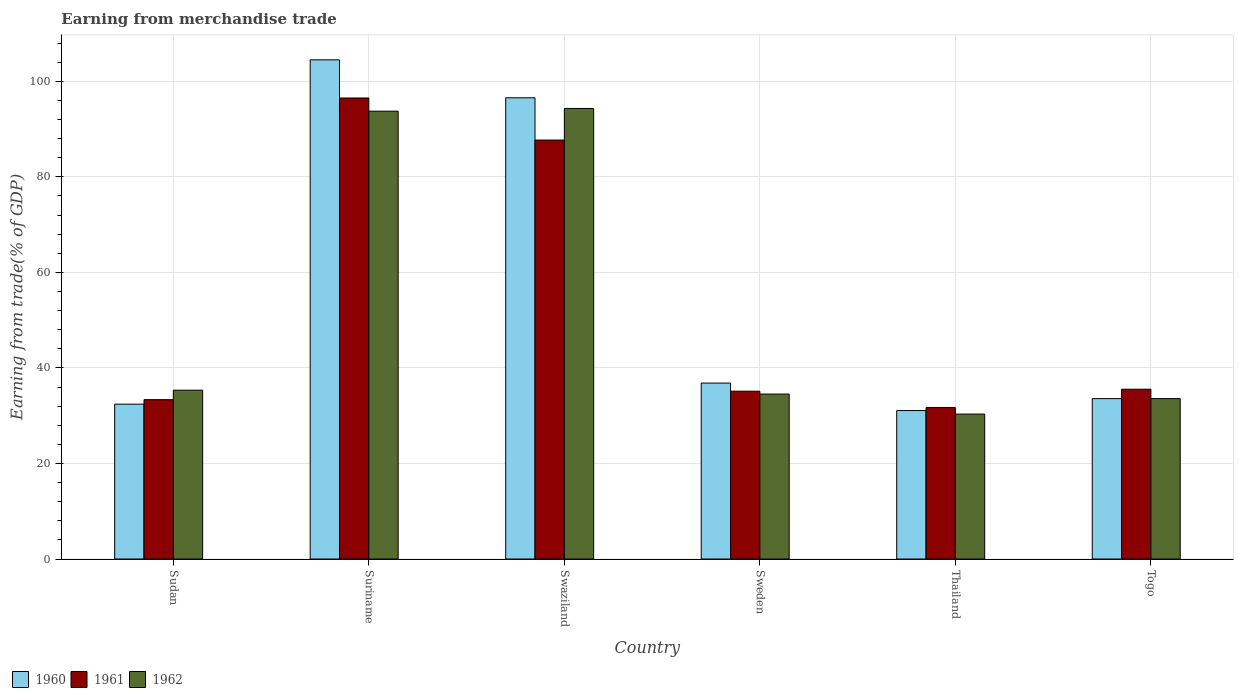How many groups of bars are there?
Make the answer very short. 6. What is the label of the 5th group of bars from the left?
Give a very brief answer. Thailand. What is the earnings from trade in 1961 in Swaziland?
Your response must be concise. 87.71. Across all countries, what is the maximum earnings from trade in 1962?
Your response must be concise. 94.33. Across all countries, what is the minimum earnings from trade in 1962?
Your response must be concise. 30.34. In which country was the earnings from trade in 1961 maximum?
Offer a very short reply. Suriname. In which country was the earnings from trade in 1960 minimum?
Provide a succinct answer. Thailand. What is the total earnings from trade in 1961 in the graph?
Keep it short and to the point. 319.97. What is the difference between the earnings from trade in 1962 in Swaziland and that in Sweden?
Your response must be concise. 59.79. What is the difference between the earnings from trade in 1961 in Sudan and the earnings from trade in 1962 in Suriname?
Your answer should be compact. -60.4. What is the average earnings from trade in 1960 per country?
Give a very brief answer. 55.83. What is the difference between the earnings from trade of/in 1962 and earnings from trade of/in 1960 in Swaziland?
Provide a short and direct response. -2.23. What is the ratio of the earnings from trade in 1960 in Suriname to that in Thailand?
Ensure brevity in your answer.  3.36. Is the earnings from trade in 1962 in Sweden less than that in Togo?
Provide a short and direct response. No. What is the difference between the highest and the second highest earnings from trade in 1962?
Your answer should be compact. -58.41. What is the difference between the highest and the lowest earnings from trade in 1961?
Keep it short and to the point. 64.81. Is the sum of the earnings from trade in 1961 in Swaziland and Sweden greater than the maximum earnings from trade in 1962 across all countries?
Offer a terse response. Yes. What does the 1st bar from the right in Sudan represents?
Offer a very short reply. 1962. How many bars are there?
Provide a succinct answer. 18. How many countries are there in the graph?
Your answer should be compact. 6. Where does the legend appear in the graph?
Keep it short and to the point. Bottom left. How are the legend labels stacked?
Your answer should be compact. Horizontal. What is the title of the graph?
Your answer should be compact. Earning from merchandise trade. What is the label or title of the Y-axis?
Offer a very short reply. Earning from trade(% of GDP). What is the Earning from trade(% of GDP) in 1960 in Sudan?
Ensure brevity in your answer.  32.42. What is the Earning from trade(% of GDP) in 1961 in Sudan?
Your answer should be compact. 33.36. What is the Earning from trade(% of GDP) in 1962 in Sudan?
Offer a very short reply. 35.34. What is the Earning from trade(% of GDP) of 1960 in Suriname?
Your answer should be very brief. 104.5. What is the Earning from trade(% of GDP) in 1961 in Suriname?
Ensure brevity in your answer.  96.51. What is the Earning from trade(% of GDP) in 1962 in Suriname?
Ensure brevity in your answer.  93.76. What is the Earning from trade(% of GDP) of 1960 in Swaziland?
Your answer should be very brief. 96.56. What is the Earning from trade(% of GDP) in 1961 in Swaziland?
Make the answer very short. 87.71. What is the Earning from trade(% of GDP) in 1962 in Swaziland?
Ensure brevity in your answer.  94.33. What is the Earning from trade(% of GDP) of 1960 in Sweden?
Your answer should be compact. 36.83. What is the Earning from trade(% of GDP) of 1961 in Sweden?
Your response must be concise. 35.13. What is the Earning from trade(% of GDP) in 1962 in Sweden?
Your response must be concise. 34.53. What is the Earning from trade(% of GDP) in 1960 in Thailand?
Your answer should be compact. 31.08. What is the Earning from trade(% of GDP) in 1961 in Thailand?
Make the answer very short. 31.71. What is the Earning from trade(% of GDP) in 1962 in Thailand?
Ensure brevity in your answer.  30.34. What is the Earning from trade(% of GDP) of 1960 in Togo?
Offer a very short reply. 33.58. What is the Earning from trade(% of GDP) of 1961 in Togo?
Provide a short and direct response. 35.55. What is the Earning from trade(% of GDP) in 1962 in Togo?
Give a very brief answer. 33.58. Across all countries, what is the maximum Earning from trade(% of GDP) in 1960?
Ensure brevity in your answer.  104.5. Across all countries, what is the maximum Earning from trade(% of GDP) in 1961?
Make the answer very short. 96.51. Across all countries, what is the maximum Earning from trade(% of GDP) of 1962?
Offer a terse response. 94.33. Across all countries, what is the minimum Earning from trade(% of GDP) in 1960?
Give a very brief answer. 31.08. Across all countries, what is the minimum Earning from trade(% of GDP) of 1961?
Provide a short and direct response. 31.71. Across all countries, what is the minimum Earning from trade(% of GDP) of 1962?
Your answer should be compact. 30.34. What is the total Earning from trade(% of GDP) in 1960 in the graph?
Provide a succinct answer. 334.97. What is the total Earning from trade(% of GDP) in 1961 in the graph?
Offer a very short reply. 319.97. What is the total Earning from trade(% of GDP) of 1962 in the graph?
Your answer should be very brief. 321.89. What is the difference between the Earning from trade(% of GDP) of 1960 in Sudan and that in Suriname?
Make the answer very short. -72.09. What is the difference between the Earning from trade(% of GDP) in 1961 in Sudan and that in Suriname?
Ensure brevity in your answer.  -63.16. What is the difference between the Earning from trade(% of GDP) of 1962 in Sudan and that in Suriname?
Provide a succinct answer. -58.41. What is the difference between the Earning from trade(% of GDP) in 1960 in Sudan and that in Swaziland?
Your answer should be compact. -64.14. What is the difference between the Earning from trade(% of GDP) in 1961 in Sudan and that in Swaziland?
Offer a terse response. -54.35. What is the difference between the Earning from trade(% of GDP) in 1962 in Sudan and that in Swaziland?
Your answer should be very brief. -58.98. What is the difference between the Earning from trade(% of GDP) of 1960 in Sudan and that in Sweden?
Provide a short and direct response. -4.41. What is the difference between the Earning from trade(% of GDP) in 1961 in Sudan and that in Sweden?
Your response must be concise. -1.78. What is the difference between the Earning from trade(% of GDP) of 1962 in Sudan and that in Sweden?
Provide a short and direct response. 0.81. What is the difference between the Earning from trade(% of GDP) in 1960 in Sudan and that in Thailand?
Offer a terse response. 1.34. What is the difference between the Earning from trade(% of GDP) of 1961 in Sudan and that in Thailand?
Offer a very short reply. 1.65. What is the difference between the Earning from trade(% of GDP) in 1962 in Sudan and that in Thailand?
Your response must be concise. 5. What is the difference between the Earning from trade(% of GDP) in 1960 in Sudan and that in Togo?
Provide a short and direct response. -1.16. What is the difference between the Earning from trade(% of GDP) in 1961 in Sudan and that in Togo?
Your answer should be compact. -2.19. What is the difference between the Earning from trade(% of GDP) in 1962 in Sudan and that in Togo?
Provide a short and direct response. 1.76. What is the difference between the Earning from trade(% of GDP) of 1960 in Suriname and that in Swaziland?
Provide a short and direct response. 7.94. What is the difference between the Earning from trade(% of GDP) in 1961 in Suriname and that in Swaziland?
Provide a short and direct response. 8.8. What is the difference between the Earning from trade(% of GDP) of 1962 in Suriname and that in Swaziland?
Give a very brief answer. -0.57. What is the difference between the Earning from trade(% of GDP) of 1960 in Suriname and that in Sweden?
Provide a succinct answer. 67.67. What is the difference between the Earning from trade(% of GDP) in 1961 in Suriname and that in Sweden?
Provide a short and direct response. 61.38. What is the difference between the Earning from trade(% of GDP) in 1962 in Suriname and that in Sweden?
Provide a succinct answer. 59.22. What is the difference between the Earning from trade(% of GDP) in 1960 in Suriname and that in Thailand?
Make the answer very short. 73.43. What is the difference between the Earning from trade(% of GDP) of 1961 in Suriname and that in Thailand?
Keep it short and to the point. 64.81. What is the difference between the Earning from trade(% of GDP) of 1962 in Suriname and that in Thailand?
Provide a succinct answer. 63.41. What is the difference between the Earning from trade(% of GDP) in 1960 in Suriname and that in Togo?
Your answer should be very brief. 70.93. What is the difference between the Earning from trade(% of GDP) in 1961 in Suriname and that in Togo?
Give a very brief answer. 60.97. What is the difference between the Earning from trade(% of GDP) in 1962 in Suriname and that in Togo?
Your response must be concise. 60.17. What is the difference between the Earning from trade(% of GDP) in 1960 in Swaziland and that in Sweden?
Offer a very short reply. 59.73. What is the difference between the Earning from trade(% of GDP) in 1961 in Swaziland and that in Sweden?
Offer a very short reply. 52.58. What is the difference between the Earning from trade(% of GDP) in 1962 in Swaziland and that in Sweden?
Your answer should be very brief. 59.79. What is the difference between the Earning from trade(% of GDP) in 1960 in Swaziland and that in Thailand?
Offer a very short reply. 65.48. What is the difference between the Earning from trade(% of GDP) in 1961 in Swaziland and that in Thailand?
Your answer should be compact. 56. What is the difference between the Earning from trade(% of GDP) of 1962 in Swaziland and that in Thailand?
Provide a succinct answer. 63.98. What is the difference between the Earning from trade(% of GDP) of 1960 in Swaziland and that in Togo?
Your answer should be compact. 62.98. What is the difference between the Earning from trade(% of GDP) of 1961 in Swaziland and that in Togo?
Provide a succinct answer. 52.16. What is the difference between the Earning from trade(% of GDP) in 1962 in Swaziland and that in Togo?
Your answer should be very brief. 60.74. What is the difference between the Earning from trade(% of GDP) of 1960 in Sweden and that in Thailand?
Your answer should be very brief. 5.75. What is the difference between the Earning from trade(% of GDP) of 1961 in Sweden and that in Thailand?
Offer a terse response. 3.43. What is the difference between the Earning from trade(% of GDP) of 1962 in Sweden and that in Thailand?
Your answer should be compact. 4.19. What is the difference between the Earning from trade(% of GDP) in 1960 in Sweden and that in Togo?
Make the answer very short. 3.25. What is the difference between the Earning from trade(% of GDP) in 1961 in Sweden and that in Togo?
Ensure brevity in your answer.  -0.41. What is the difference between the Earning from trade(% of GDP) of 1962 in Sweden and that in Togo?
Ensure brevity in your answer.  0.95. What is the difference between the Earning from trade(% of GDP) of 1960 in Thailand and that in Togo?
Provide a succinct answer. -2.5. What is the difference between the Earning from trade(% of GDP) of 1961 in Thailand and that in Togo?
Keep it short and to the point. -3.84. What is the difference between the Earning from trade(% of GDP) of 1962 in Thailand and that in Togo?
Ensure brevity in your answer.  -3.24. What is the difference between the Earning from trade(% of GDP) of 1960 in Sudan and the Earning from trade(% of GDP) of 1961 in Suriname?
Offer a very short reply. -64.1. What is the difference between the Earning from trade(% of GDP) of 1960 in Sudan and the Earning from trade(% of GDP) of 1962 in Suriname?
Provide a succinct answer. -61.34. What is the difference between the Earning from trade(% of GDP) of 1961 in Sudan and the Earning from trade(% of GDP) of 1962 in Suriname?
Your answer should be very brief. -60.4. What is the difference between the Earning from trade(% of GDP) in 1960 in Sudan and the Earning from trade(% of GDP) in 1961 in Swaziland?
Provide a succinct answer. -55.29. What is the difference between the Earning from trade(% of GDP) of 1960 in Sudan and the Earning from trade(% of GDP) of 1962 in Swaziland?
Your answer should be very brief. -61.91. What is the difference between the Earning from trade(% of GDP) in 1961 in Sudan and the Earning from trade(% of GDP) in 1962 in Swaziland?
Give a very brief answer. -60.97. What is the difference between the Earning from trade(% of GDP) of 1960 in Sudan and the Earning from trade(% of GDP) of 1961 in Sweden?
Your answer should be very brief. -2.72. What is the difference between the Earning from trade(% of GDP) of 1960 in Sudan and the Earning from trade(% of GDP) of 1962 in Sweden?
Ensure brevity in your answer.  -2.12. What is the difference between the Earning from trade(% of GDP) of 1961 in Sudan and the Earning from trade(% of GDP) of 1962 in Sweden?
Give a very brief answer. -1.18. What is the difference between the Earning from trade(% of GDP) of 1960 in Sudan and the Earning from trade(% of GDP) of 1961 in Thailand?
Your answer should be very brief. 0.71. What is the difference between the Earning from trade(% of GDP) in 1960 in Sudan and the Earning from trade(% of GDP) in 1962 in Thailand?
Keep it short and to the point. 2.08. What is the difference between the Earning from trade(% of GDP) of 1961 in Sudan and the Earning from trade(% of GDP) of 1962 in Thailand?
Your answer should be compact. 3.01. What is the difference between the Earning from trade(% of GDP) of 1960 in Sudan and the Earning from trade(% of GDP) of 1961 in Togo?
Keep it short and to the point. -3.13. What is the difference between the Earning from trade(% of GDP) of 1960 in Sudan and the Earning from trade(% of GDP) of 1962 in Togo?
Your response must be concise. -1.17. What is the difference between the Earning from trade(% of GDP) in 1961 in Sudan and the Earning from trade(% of GDP) in 1962 in Togo?
Your answer should be compact. -0.23. What is the difference between the Earning from trade(% of GDP) of 1960 in Suriname and the Earning from trade(% of GDP) of 1961 in Swaziland?
Your answer should be very brief. 16.79. What is the difference between the Earning from trade(% of GDP) of 1960 in Suriname and the Earning from trade(% of GDP) of 1962 in Swaziland?
Your response must be concise. 10.18. What is the difference between the Earning from trade(% of GDP) in 1961 in Suriname and the Earning from trade(% of GDP) in 1962 in Swaziland?
Offer a very short reply. 2.19. What is the difference between the Earning from trade(% of GDP) of 1960 in Suriname and the Earning from trade(% of GDP) of 1961 in Sweden?
Your answer should be very brief. 69.37. What is the difference between the Earning from trade(% of GDP) in 1960 in Suriname and the Earning from trade(% of GDP) in 1962 in Sweden?
Your answer should be compact. 69.97. What is the difference between the Earning from trade(% of GDP) of 1961 in Suriname and the Earning from trade(% of GDP) of 1962 in Sweden?
Your answer should be very brief. 61.98. What is the difference between the Earning from trade(% of GDP) of 1960 in Suriname and the Earning from trade(% of GDP) of 1961 in Thailand?
Provide a succinct answer. 72.8. What is the difference between the Earning from trade(% of GDP) in 1960 in Suriname and the Earning from trade(% of GDP) in 1962 in Thailand?
Your answer should be very brief. 74.16. What is the difference between the Earning from trade(% of GDP) in 1961 in Suriname and the Earning from trade(% of GDP) in 1962 in Thailand?
Provide a succinct answer. 66.17. What is the difference between the Earning from trade(% of GDP) in 1960 in Suriname and the Earning from trade(% of GDP) in 1961 in Togo?
Give a very brief answer. 68.96. What is the difference between the Earning from trade(% of GDP) in 1960 in Suriname and the Earning from trade(% of GDP) in 1962 in Togo?
Make the answer very short. 70.92. What is the difference between the Earning from trade(% of GDP) in 1961 in Suriname and the Earning from trade(% of GDP) in 1962 in Togo?
Offer a terse response. 62.93. What is the difference between the Earning from trade(% of GDP) of 1960 in Swaziland and the Earning from trade(% of GDP) of 1961 in Sweden?
Give a very brief answer. 61.43. What is the difference between the Earning from trade(% of GDP) of 1960 in Swaziland and the Earning from trade(% of GDP) of 1962 in Sweden?
Give a very brief answer. 62.03. What is the difference between the Earning from trade(% of GDP) in 1961 in Swaziland and the Earning from trade(% of GDP) in 1962 in Sweden?
Give a very brief answer. 53.18. What is the difference between the Earning from trade(% of GDP) in 1960 in Swaziland and the Earning from trade(% of GDP) in 1961 in Thailand?
Offer a terse response. 64.85. What is the difference between the Earning from trade(% of GDP) of 1960 in Swaziland and the Earning from trade(% of GDP) of 1962 in Thailand?
Keep it short and to the point. 66.22. What is the difference between the Earning from trade(% of GDP) in 1961 in Swaziland and the Earning from trade(% of GDP) in 1962 in Thailand?
Keep it short and to the point. 57.37. What is the difference between the Earning from trade(% of GDP) of 1960 in Swaziland and the Earning from trade(% of GDP) of 1961 in Togo?
Give a very brief answer. 61.01. What is the difference between the Earning from trade(% of GDP) in 1960 in Swaziland and the Earning from trade(% of GDP) in 1962 in Togo?
Your response must be concise. 62.98. What is the difference between the Earning from trade(% of GDP) in 1961 in Swaziland and the Earning from trade(% of GDP) in 1962 in Togo?
Keep it short and to the point. 54.13. What is the difference between the Earning from trade(% of GDP) of 1960 in Sweden and the Earning from trade(% of GDP) of 1961 in Thailand?
Give a very brief answer. 5.13. What is the difference between the Earning from trade(% of GDP) in 1960 in Sweden and the Earning from trade(% of GDP) in 1962 in Thailand?
Ensure brevity in your answer.  6.49. What is the difference between the Earning from trade(% of GDP) of 1961 in Sweden and the Earning from trade(% of GDP) of 1962 in Thailand?
Your response must be concise. 4.79. What is the difference between the Earning from trade(% of GDP) in 1960 in Sweden and the Earning from trade(% of GDP) in 1961 in Togo?
Your answer should be very brief. 1.29. What is the difference between the Earning from trade(% of GDP) of 1960 in Sweden and the Earning from trade(% of GDP) of 1962 in Togo?
Provide a succinct answer. 3.25. What is the difference between the Earning from trade(% of GDP) in 1961 in Sweden and the Earning from trade(% of GDP) in 1962 in Togo?
Give a very brief answer. 1.55. What is the difference between the Earning from trade(% of GDP) of 1960 in Thailand and the Earning from trade(% of GDP) of 1961 in Togo?
Ensure brevity in your answer.  -4.47. What is the difference between the Earning from trade(% of GDP) of 1960 in Thailand and the Earning from trade(% of GDP) of 1962 in Togo?
Your answer should be compact. -2.51. What is the difference between the Earning from trade(% of GDP) of 1961 in Thailand and the Earning from trade(% of GDP) of 1962 in Togo?
Your answer should be compact. -1.88. What is the average Earning from trade(% of GDP) in 1960 per country?
Your answer should be compact. 55.83. What is the average Earning from trade(% of GDP) in 1961 per country?
Offer a terse response. 53.33. What is the average Earning from trade(% of GDP) of 1962 per country?
Your answer should be compact. 53.65. What is the difference between the Earning from trade(% of GDP) of 1960 and Earning from trade(% of GDP) of 1961 in Sudan?
Offer a terse response. -0.94. What is the difference between the Earning from trade(% of GDP) in 1960 and Earning from trade(% of GDP) in 1962 in Sudan?
Make the answer very short. -2.92. What is the difference between the Earning from trade(% of GDP) in 1961 and Earning from trade(% of GDP) in 1962 in Sudan?
Your answer should be compact. -1.99. What is the difference between the Earning from trade(% of GDP) of 1960 and Earning from trade(% of GDP) of 1961 in Suriname?
Your answer should be very brief. 7.99. What is the difference between the Earning from trade(% of GDP) of 1960 and Earning from trade(% of GDP) of 1962 in Suriname?
Keep it short and to the point. 10.75. What is the difference between the Earning from trade(% of GDP) of 1961 and Earning from trade(% of GDP) of 1962 in Suriname?
Provide a short and direct response. 2.76. What is the difference between the Earning from trade(% of GDP) in 1960 and Earning from trade(% of GDP) in 1961 in Swaziland?
Keep it short and to the point. 8.85. What is the difference between the Earning from trade(% of GDP) of 1960 and Earning from trade(% of GDP) of 1962 in Swaziland?
Offer a terse response. 2.23. What is the difference between the Earning from trade(% of GDP) of 1961 and Earning from trade(% of GDP) of 1962 in Swaziland?
Make the answer very short. -6.62. What is the difference between the Earning from trade(% of GDP) of 1960 and Earning from trade(% of GDP) of 1961 in Sweden?
Offer a terse response. 1.7. What is the difference between the Earning from trade(% of GDP) in 1960 and Earning from trade(% of GDP) in 1962 in Sweden?
Offer a very short reply. 2.3. What is the difference between the Earning from trade(% of GDP) of 1961 and Earning from trade(% of GDP) of 1962 in Sweden?
Ensure brevity in your answer.  0.6. What is the difference between the Earning from trade(% of GDP) of 1960 and Earning from trade(% of GDP) of 1961 in Thailand?
Give a very brief answer. -0.63. What is the difference between the Earning from trade(% of GDP) of 1960 and Earning from trade(% of GDP) of 1962 in Thailand?
Keep it short and to the point. 0.74. What is the difference between the Earning from trade(% of GDP) in 1961 and Earning from trade(% of GDP) in 1962 in Thailand?
Ensure brevity in your answer.  1.36. What is the difference between the Earning from trade(% of GDP) in 1960 and Earning from trade(% of GDP) in 1961 in Togo?
Your response must be concise. -1.97. What is the difference between the Earning from trade(% of GDP) of 1960 and Earning from trade(% of GDP) of 1962 in Togo?
Give a very brief answer. -0.01. What is the difference between the Earning from trade(% of GDP) in 1961 and Earning from trade(% of GDP) in 1962 in Togo?
Provide a short and direct response. 1.96. What is the ratio of the Earning from trade(% of GDP) of 1960 in Sudan to that in Suriname?
Provide a succinct answer. 0.31. What is the ratio of the Earning from trade(% of GDP) of 1961 in Sudan to that in Suriname?
Offer a very short reply. 0.35. What is the ratio of the Earning from trade(% of GDP) in 1962 in Sudan to that in Suriname?
Your response must be concise. 0.38. What is the ratio of the Earning from trade(% of GDP) in 1960 in Sudan to that in Swaziland?
Ensure brevity in your answer.  0.34. What is the ratio of the Earning from trade(% of GDP) in 1961 in Sudan to that in Swaziland?
Your answer should be compact. 0.38. What is the ratio of the Earning from trade(% of GDP) of 1962 in Sudan to that in Swaziland?
Make the answer very short. 0.37. What is the ratio of the Earning from trade(% of GDP) of 1960 in Sudan to that in Sweden?
Provide a succinct answer. 0.88. What is the ratio of the Earning from trade(% of GDP) in 1961 in Sudan to that in Sweden?
Your answer should be compact. 0.95. What is the ratio of the Earning from trade(% of GDP) of 1962 in Sudan to that in Sweden?
Make the answer very short. 1.02. What is the ratio of the Earning from trade(% of GDP) in 1960 in Sudan to that in Thailand?
Offer a very short reply. 1.04. What is the ratio of the Earning from trade(% of GDP) of 1961 in Sudan to that in Thailand?
Your response must be concise. 1.05. What is the ratio of the Earning from trade(% of GDP) of 1962 in Sudan to that in Thailand?
Provide a succinct answer. 1.16. What is the ratio of the Earning from trade(% of GDP) in 1960 in Sudan to that in Togo?
Provide a succinct answer. 0.97. What is the ratio of the Earning from trade(% of GDP) of 1961 in Sudan to that in Togo?
Your answer should be compact. 0.94. What is the ratio of the Earning from trade(% of GDP) of 1962 in Sudan to that in Togo?
Your answer should be very brief. 1.05. What is the ratio of the Earning from trade(% of GDP) of 1960 in Suriname to that in Swaziland?
Your answer should be compact. 1.08. What is the ratio of the Earning from trade(% of GDP) in 1961 in Suriname to that in Swaziland?
Your answer should be compact. 1.1. What is the ratio of the Earning from trade(% of GDP) in 1962 in Suriname to that in Swaziland?
Offer a very short reply. 0.99. What is the ratio of the Earning from trade(% of GDP) in 1960 in Suriname to that in Sweden?
Offer a very short reply. 2.84. What is the ratio of the Earning from trade(% of GDP) of 1961 in Suriname to that in Sweden?
Offer a very short reply. 2.75. What is the ratio of the Earning from trade(% of GDP) in 1962 in Suriname to that in Sweden?
Make the answer very short. 2.71. What is the ratio of the Earning from trade(% of GDP) of 1960 in Suriname to that in Thailand?
Give a very brief answer. 3.36. What is the ratio of the Earning from trade(% of GDP) in 1961 in Suriname to that in Thailand?
Your answer should be compact. 3.04. What is the ratio of the Earning from trade(% of GDP) in 1962 in Suriname to that in Thailand?
Your answer should be very brief. 3.09. What is the ratio of the Earning from trade(% of GDP) of 1960 in Suriname to that in Togo?
Offer a terse response. 3.11. What is the ratio of the Earning from trade(% of GDP) of 1961 in Suriname to that in Togo?
Give a very brief answer. 2.72. What is the ratio of the Earning from trade(% of GDP) in 1962 in Suriname to that in Togo?
Your answer should be compact. 2.79. What is the ratio of the Earning from trade(% of GDP) of 1960 in Swaziland to that in Sweden?
Offer a very short reply. 2.62. What is the ratio of the Earning from trade(% of GDP) of 1961 in Swaziland to that in Sweden?
Offer a very short reply. 2.5. What is the ratio of the Earning from trade(% of GDP) in 1962 in Swaziland to that in Sweden?
Make the answer very short. 2.73. What is the ratio of the Earning from trade(% of GDP) of 1960 in Swaziland to that in Thailand?
Your answer should be compact. 3.11. What is the ratio of the Earning from trade(% of GDP) in 1961 in Swaziland to that in Thailand?
Ensure brevity in your answer.  2.77. What is the ratio of the Earning from trade(% of GDP) of 1962 in Swaziland to that in Thailand?
Your answer should be compact. 3.11. What is the ratio of the Earning from trade(% of GDP) in 1960 in Swaziland to that in Togo?
Keep it short and to the point. 2.88. What is the ratio of the Earning from trade(% of GDP) in 1961 in Swaziland to that in Togo?
Your response must be concise. 2.47. What is the ratio of the Earning from trade(% of GDP) of 1962 in Swaziland to that in Togo?
Provide a succinct answer. 2.81. What is the ratio of the Earning from trade(% of GDP) of 1960 in Sweden to that in Thailand?
Your answer should be very brief. 1.19. What is the ratio of the Earning from trade(% of GDP) in 1961 in Sweden to that in Thailand?
Your answer should be compact. 1.11. What is the ratio of the Earning from trade(% of GDP) in 1962 in Sweden to that in Thailand?
Provide a succinct answer. 1.14. What is the ratio of the Earning from trade(% of GDP) of 1960 in Sweden to that in Togo?
Keep it short and to the point. 1.1. What is the ratio of the Earning from trade(% of GDP) of 1961 in Sweden to that in Togo?
Keep it short and to the point. 0.99. What is the ratio of the Earning from trade(% of GDP) in 1962 in Sweden to that in Togo?
Your answer should be very brief. 1.03. What is the ratio of the Earning from trade(% of GDP) of 1960 in Thailand to that in Togo?
Your answer should be compact. 0.93. What is the ratio of the Earning from trade(% of GDP) in 1961 in Thailand to that in Togo?
Offer a terse response. 0.89. What is the ratio of the Earning from trade(% of GDP) of 1962 in Thailand to that in Togo?
Give a very brief answer. 0.9. What is the difference between the highest and the second highest Earning from trade(% of GDP) in 1960?
Make the answer very short. 7.94. What is the difference between the highest and the second highest Earning from trade(% of GDP) of 1961?
Provide a succinct answer. 8.8. What is the difference between the highest and the second highest Earning from trade(% of GDP) of 1962?
Provide a short and direct response. 0.57. What is the difference between the highest and the lowest Earning from trade(% of GDP) of 1960?
Provide a short and direct response. 73.43. What is the difference between the highest and the lowest Earning from trade(% of GDP) of 1961?
Offer a very short reply. 64.81. What is the difference between the highest and the lowest Earning from trade(% of GDP) in 1962?
Keep it short and to the point. 63.98. 